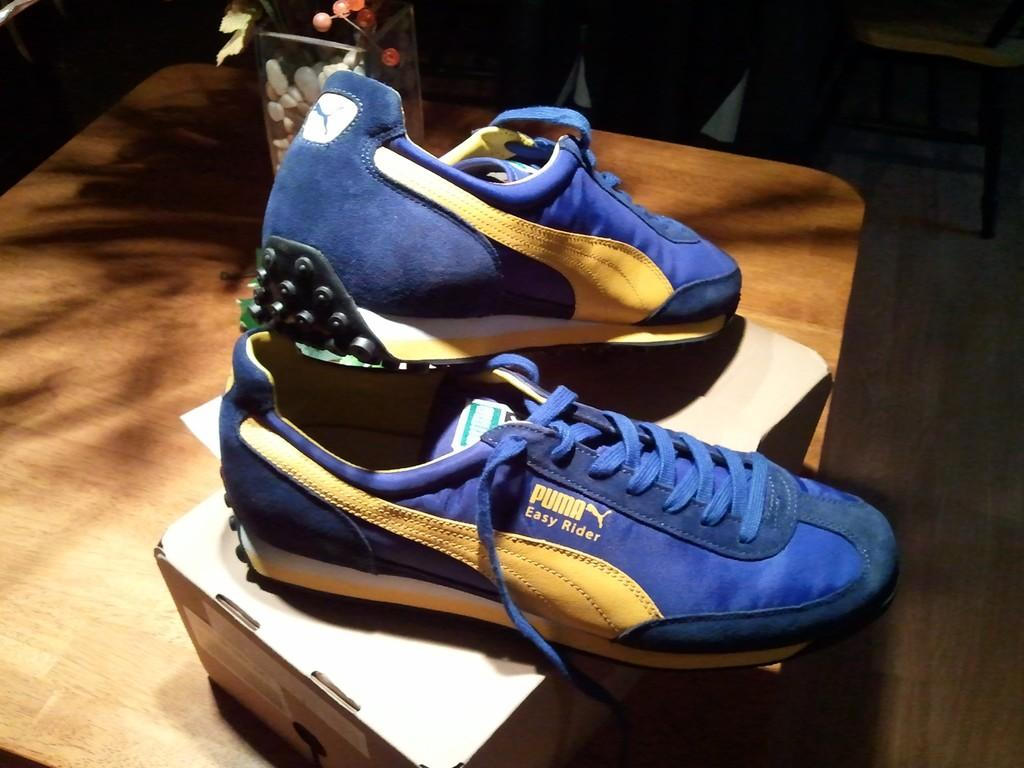What is placed on the table in the image? There is a pair of shoes and a box on the table. Can you describe the shoes on the table? The shoes are blue and yellow in color. What type of box is on the table? There is a glass box on the table. What is inside the glass box? The glass box contains a plant. What type of wine is being served in the image? There is no wine present in the image; it features a pair of shoes, a box, and a plant in a glass box. 